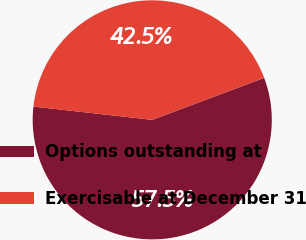Convert chart. <chart><loc_0><loc_0><loc_500><loc_500><pie_chart><fcel>Options outstanding at<fcel>Exercisable at December 31<nl><fcel>57.48%<fcel>42.52%<nl></chart> 